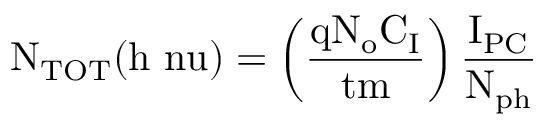<formula> <loc_0><loc_0><loc_500><loc_500>N _ { T O T } ( h \ n u ) = \left ( \frac { \mathrm { q N _ { o } } C _ { I } } { t m } \right ) \frac { I _ { P C } } { N _ { p h } }</formula> 